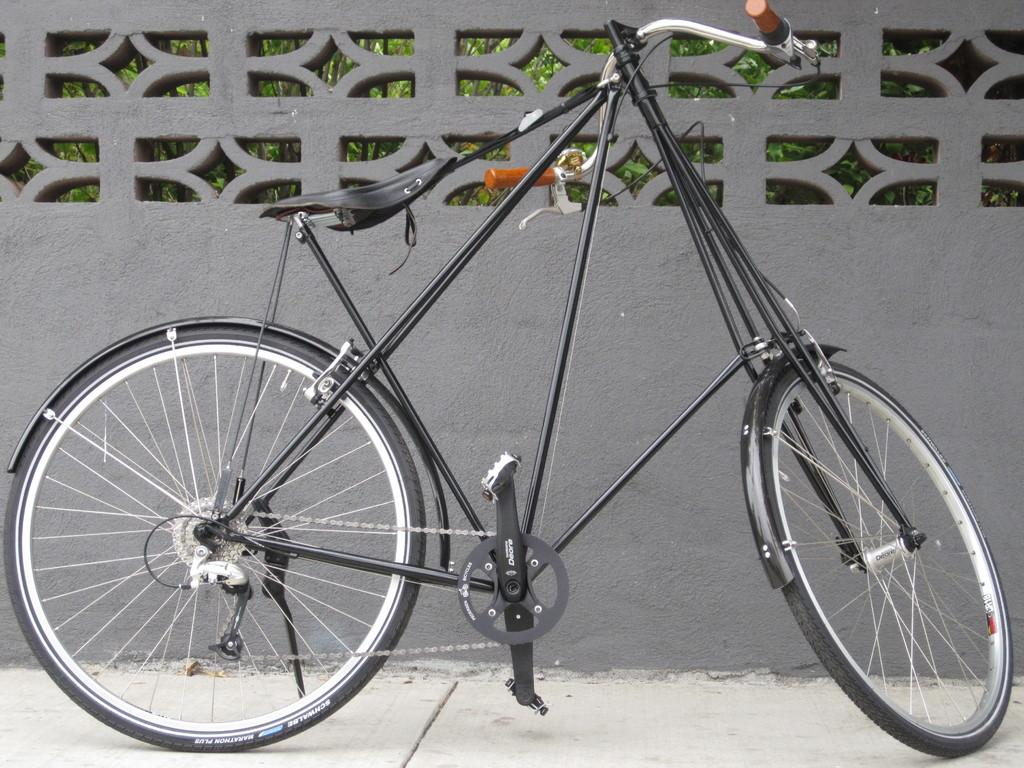What is the main subject of the image? There is a bicycle in the center of the image. Can you describe the background of the image? There is a wall in the background of the image. What type of button can be seen on the bicycle in the image? There is no button present on the bicycle in the image. Is the bicycle facing a crook in the image? There is no crook present in the image, and the direction the bicycle is facing cannot be determined from the provided facts. 